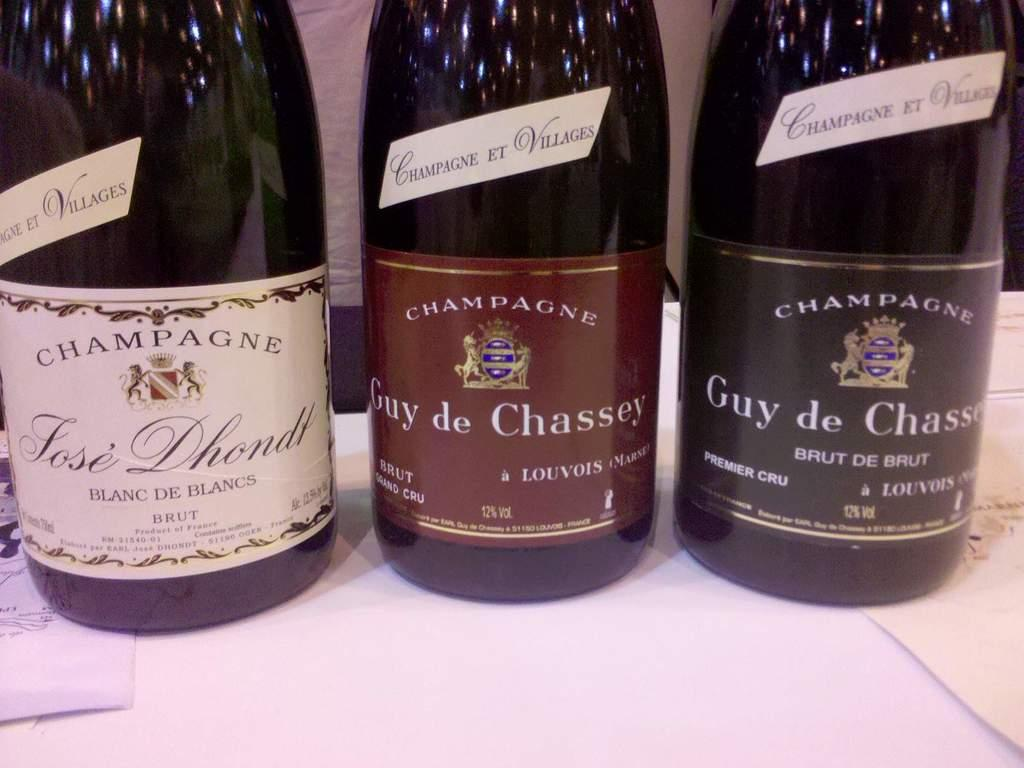Provide a one-sentence caption for the provided image. Three bottles of champagne stand next to each other. 